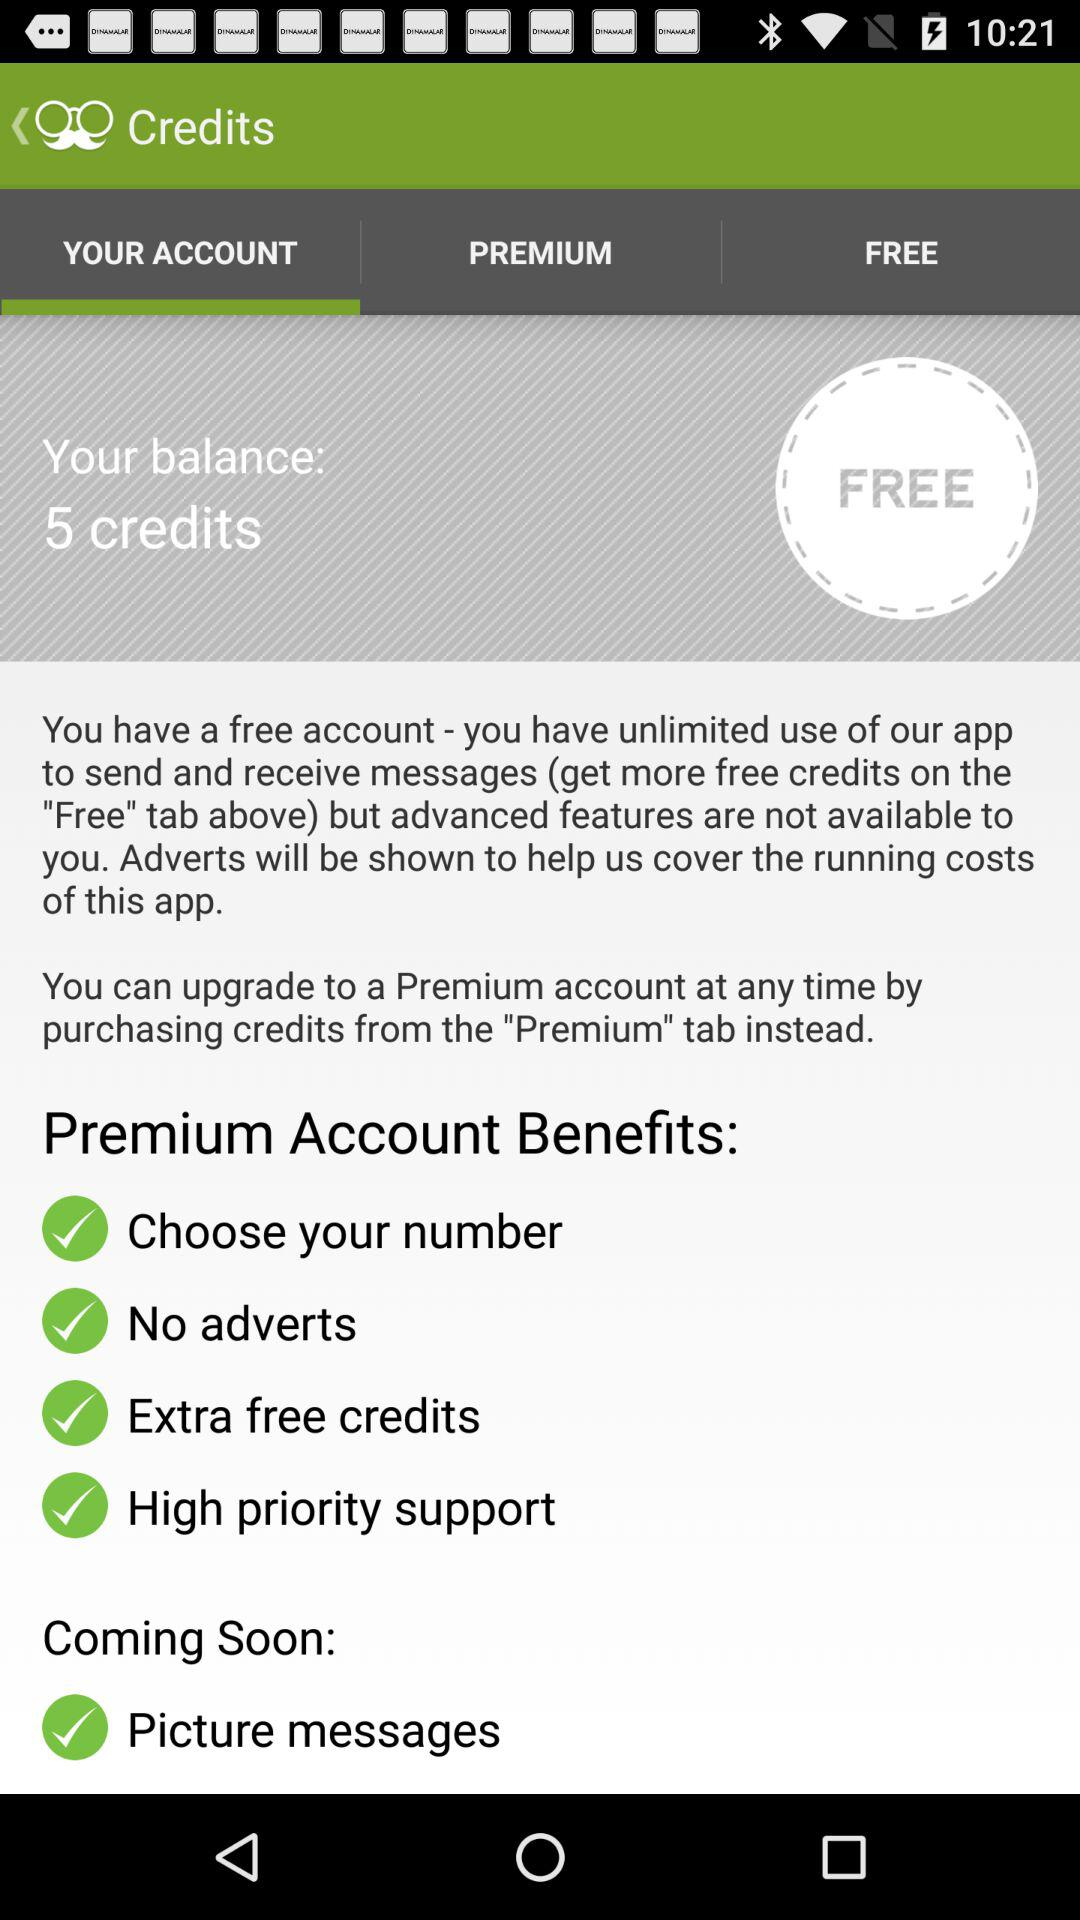How many credits do I have?
Answer the question using a single word or phrase. 5 